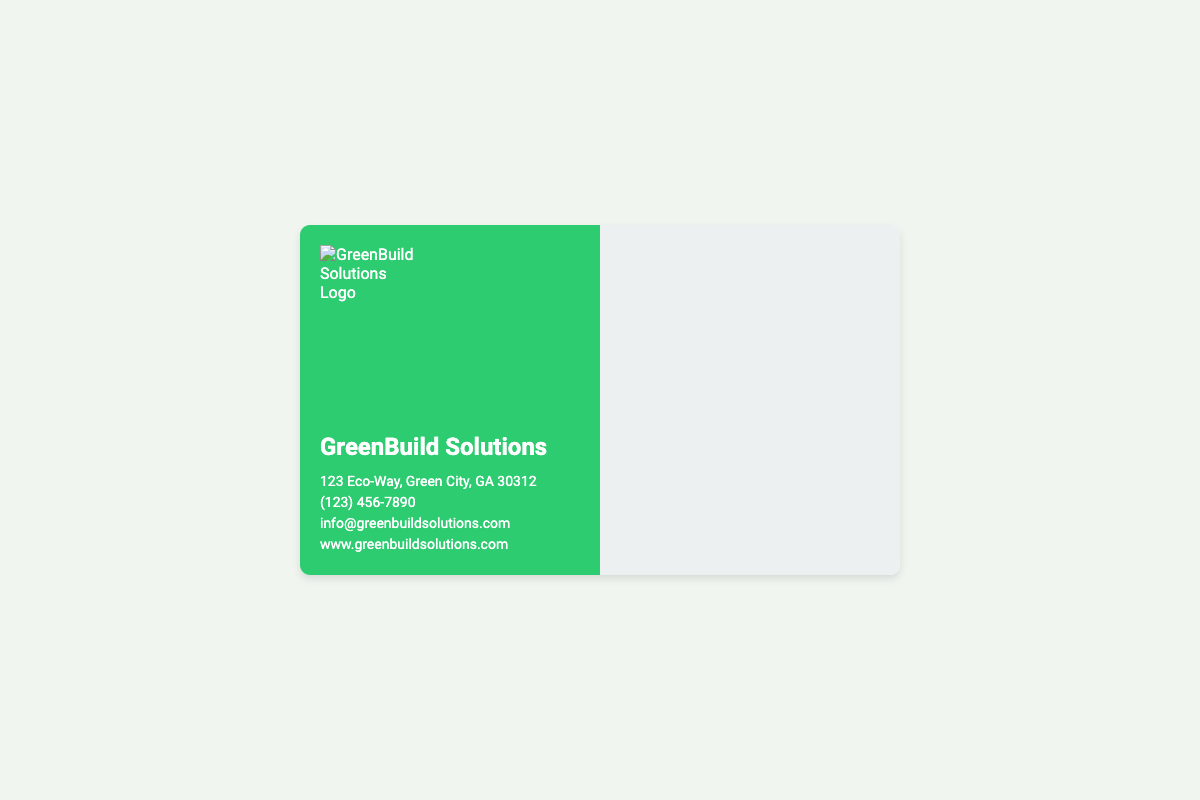What is the company name? The company name is displayed prominently on the front of the business card.
Answer: GreenBuild Solutions What is the contact phone number? The phone number is listed in the contact information section on the front.
Answer: (123) 456-7890 Which certification is represented by an icon on the back? The back of the business card includes various certifications, each represented as an icon.
Answer: ENERGY STAR How many eco-friendly certifications are displayed? The total number of certifications can be counted from the icons on the back of the card.
Answer: 7 Which award is associated with sustainable practices? The back of the card features awards related to sustainability.
Answer: Sustainable Innovation Award Which organization manages LEED certification? Reasoning based on the LEED certification icon provided on the back of the card leads to identifying the organization.
Answer: USGBC What is the primary color of the business card's front? The color scheme for the front of the business card is prominently displayed in its design.
Answer: Green What is the background color of the back of the card? The back of the card features a specific color which can be identified visually.
Answer: Light Gray 